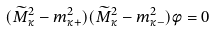<formula> <loc_0><loc_0><loc_500><loc_500>( \widetilde { M } _ { \kappa } ^ { 2 } - m _ { \kappa + } ^ { 2 } ) ( \widetilde { M } _ { \kappa } ^ { 2 } - m _ { \kappa - } ^ { 2 } ) \phi = 0</formula> 